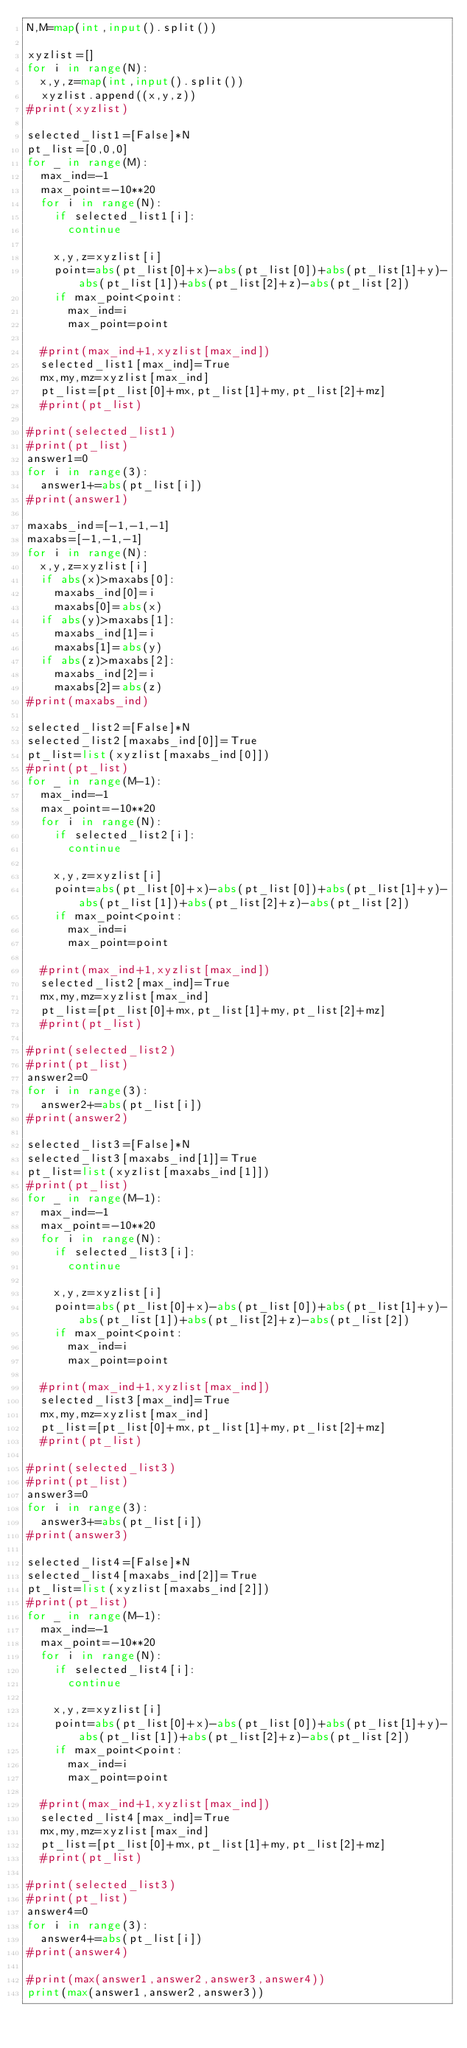<code> <loc_0><loc_0><loc_500><loc_500><_Python_>N,M=map(int,input().split())

xyzlist=[]
for i in range(N):
  x,y,z=map(int,input().split())
  xyzlist.append((x,y,z))
#print(xyzlist)

selected_list1=[False]*N
pt_list=[0,0,0]
for _ in range(M):
  max_ind=-1
  max_point=-10**20
  for i in range(N):
    if selected_list1[i]:
      continue
      
    x,y,z=xyzlist[i]    
    point=abs(pt_list[0]+x)-abs(pt_list[0])+abs(pt_list[1]+y)-abs(pt_list[1])+abs(pt_list[2]+z)-abs(pt_list[2])
    if max_point<point:
      max_ind=i
      max_point=point
      
  #print(max_ind+1,xyzlist[max_ind])  
  selected_list1[max_ind]=True
  mx,my,mz=xyzlist[max_ind]
  pt_list=[pt_list[0]+mx,pt_list[1]+my,pt_list[2]+mz]
  #print(pt_list)
  
#print(selected_list1)
#print(pt_list)
answer1=0
for i in range(3):
  answer1+=abs(pt_list[i])
#print(answer1)

maxabs_ind=[-1,-1,-1]
maxabs=[-1,-1,-1]
for i in range(N):
  x,y,z=xyzlist[i]
  if abs(x)>maxabs[0]:
    maxabs_ind[0]=i
    maxabs[0]=abs(x)
  if abs(y)>maxabs[1]:
    maxabs_ind[1]=i
    maxabs[1]=abs(y)
  if abs(z)>maxabs[2]:
    maxabs_ind[2]=i
    maxabs[2]=abs(z)
#print(maxabs_ind)
    
selected_list2=[False]*N
selected_list2[maxabs_ind[0]]=True
pt_list=list(xyzlist[maxabs_ind[0]])
#print(pt_list)
for _ in range(M-1):
  max_ind=-1
  max_point=-10**20
  for i in range(N):
    if selected_list2[i]:
      continue
      
    x,y,z=xyzlist[i]    
    point=abs(pt_list[0]+x)-abs(pt_list[0])+abs(pt_list[1]+y)-abs(pt_list[1])+abs(pt_list[2]+z)-abs(pt_list[2])
    if max_point<point:
      max_ind=i
      max_point=point
      
  #print(max_ind+1,xyzlist[max_ind])  
  selected_list2[max_ind]=True
  mx,my,mz=xyzlist[max_ind]
  pt_list=[pt_list[0]+mx,pt_list[1]+my,pt_list[2]+mz]
  #print(pt_list)
  
#print(selected_list2)
#print(pt_list)
answer2=0
for i in range(3):
  answer2+=abs(pt_list[i])
#print(answer2)

selected_list3=[False]*N
selected_list3[maxabs_ind[1]]=True
pt_list=list(xyzlist[maxabs_ind[1]])
#print(pt_list)
for _ in range(M-1):
  max_ind=-1
  max_point=-10**20
  for i in range(N):
    if selected_list3[i]:
      continue
      
    x,y,z=xyzlist[i]    
    point=abs(pt_list[0]+x)-abs(pt_list[0])+abs(pt_list[1]+y)-abs(pt_list[1])+abs(pt_list[2]+z)-abs(pt_list[2])
    if max_point<point:
      max_ind=i
      max_point=point
      
  #print(max_ind+1,xyzlist[max_ind])  
  selected_list3[max_ind]=True
  mx,my,mz=xyzlist[max_ind]
  pt_list=[pt_list[0]+mx,pt_list[1]+my,pt_list[2]+mz]
  #print(pt_list)
  
#print(selected_list3)
#print(pt_list)
answer3=0
for i in range(3):
  answer3+=abs(pt_list[i])
#print(answer3)

selected_list4=[False]*N
selected_list4[maxabs_ind[2]]=True
pt_list=list(xyzlist[maxabs_ind[2]])
#print(pt_list)
for _ in range(M-1):
  max_ind=-1
  max_point=-10**20
  for i in range(N):
    if selected_list4[i]:
      continue
      
    x,y,z=xyzlist[i]    
    point=abs(pt_list[0]+x)-abs(pt_list[0])+abs(pt_list[1]+y)-abs(pt_list[1])+abs(pt_list[2]+z)-abs(pt_list[2])
    if max_point<point:
      max_ind=i
      max_point=point
      
  #print(max_ind+1,xyzlist[max_ind])  
  selected_list4[max_ind]=True
  mx,my,mz=xyzlist[max_ind]
  pt_list=[pt_list[0]+mx,pt_list[1]+my,pt_list[2]+mz]
  #print(pt_list)
  
#print(selected_list3)
#print(pt_list)
answer4=0
for i in range(3):
  answer4+=abs(pt_list[i])
#print(answer4)

#print(max(answer1,answer2,answer3,answer4))
print(max(answer1,answer2,answer3))</code> 